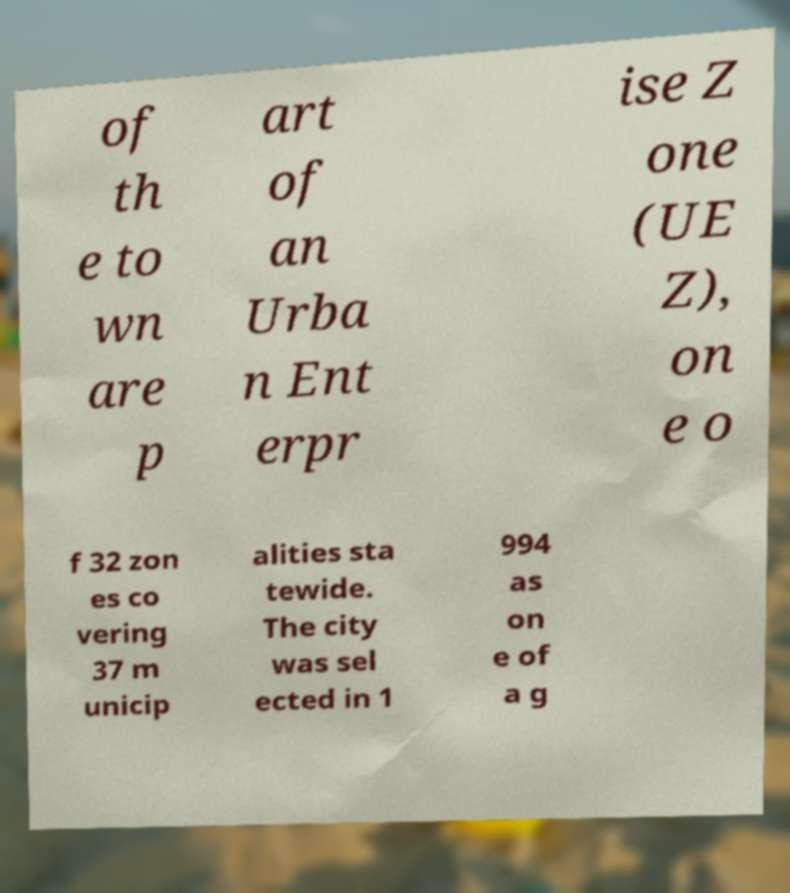There's text embedded in this image that I need extracted. Can you transcribe it verbatim? of th e to wn are p art of an Urba n Ent erpr ise Z one (UE Z), on e o f 32 zon es co vering 37 m unicip alities sta tewide. The city was sel ected in 1 994 as on e of a g 